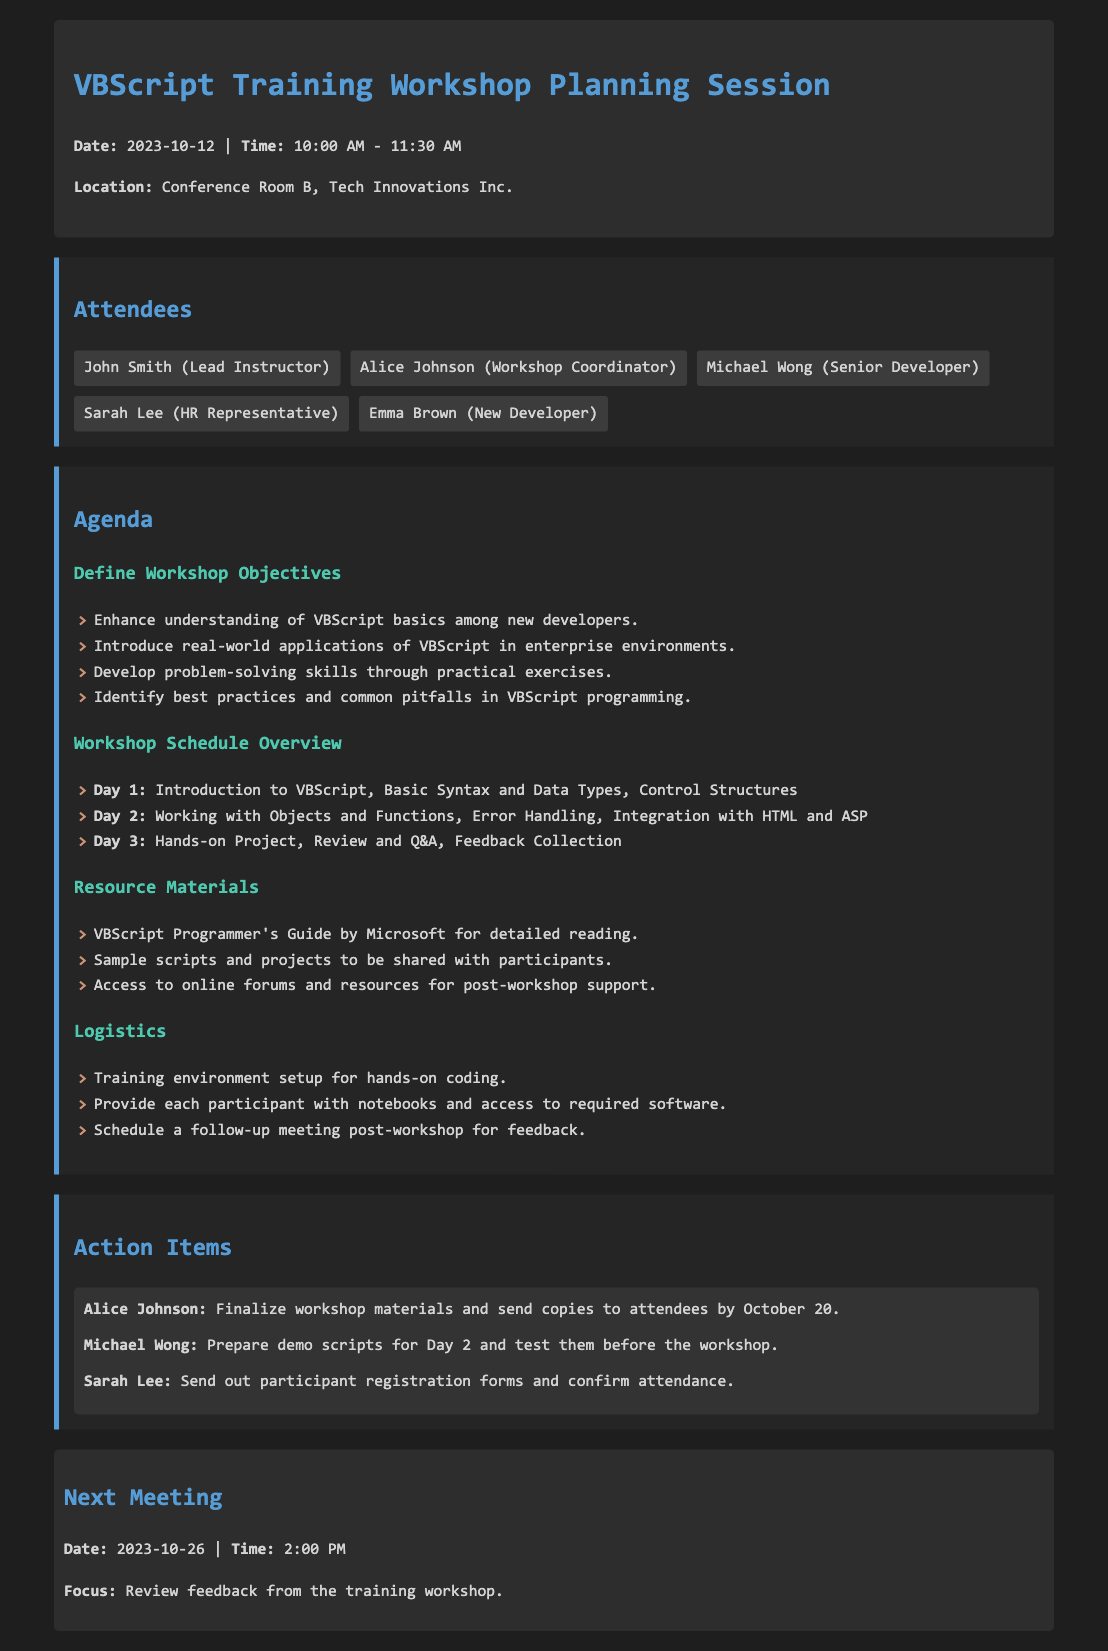what is the date of the planning session? The date of the planning session is stated in the header section of the document.
Answer: 2023-10-12 who is the lead instructor for the workshop? The lead instructor is listed among the attendees in the document.
Answer: John Smith how many days is the workshop scheduled for? The workshop schedule overview indicates the number of days the workshop will run.
Answer: 3 what is the focus of the next meeting? The focus of the next meeting is specified in the last section of the document.
Answer: Review feedback from the training workshop who is responsible for finalizing the workshop materials? The action items section lists the person responsible for this task.
Answer: Alice Johnson what is the time for the next meeting? The time for the next meeting is mentioned at the bottom of the document.
Answer: 2:00 PM name one resource material provided for the workshop. The resource materials are listed in the agenda section of the document.
Answer: VBScript Programmer's Guide by Microsoft which day focuses on hands-on projects? The specific agenda item outlines the focus for each day of the workshop.
Answer: Day 3 how many attendees are listed in the minutes? The total number of attendees can be counted from the attendees section.
Answer: 5 